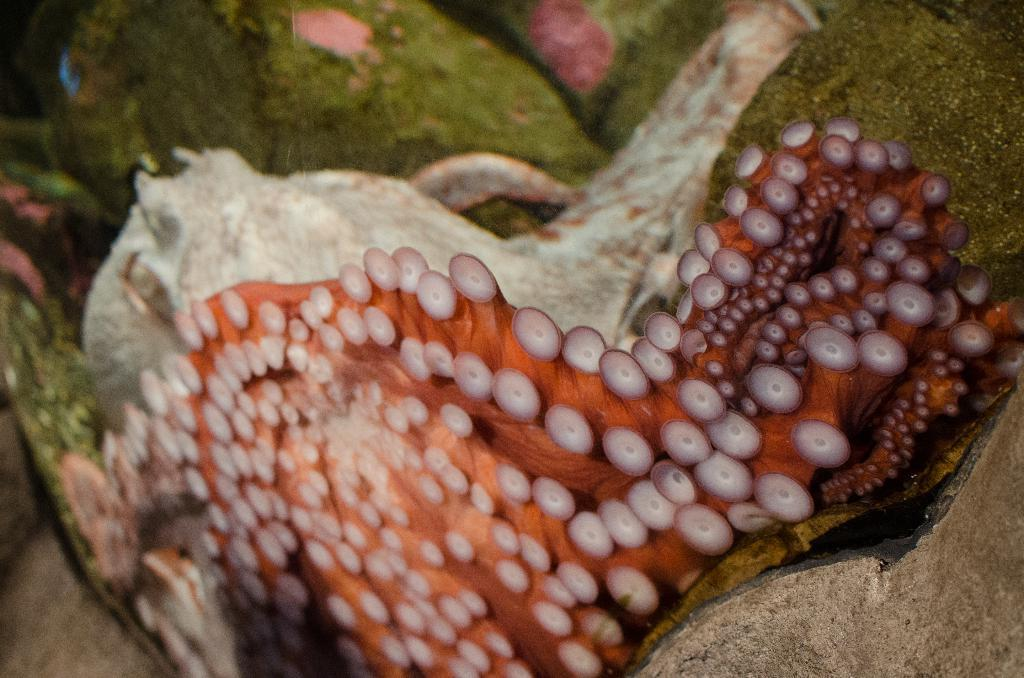What type of animal is in the image? There is an octopus in the image. What type of maid can be seen serving eggnog in the image? There is no maid or eggnog present in the image; it features an octopus. 